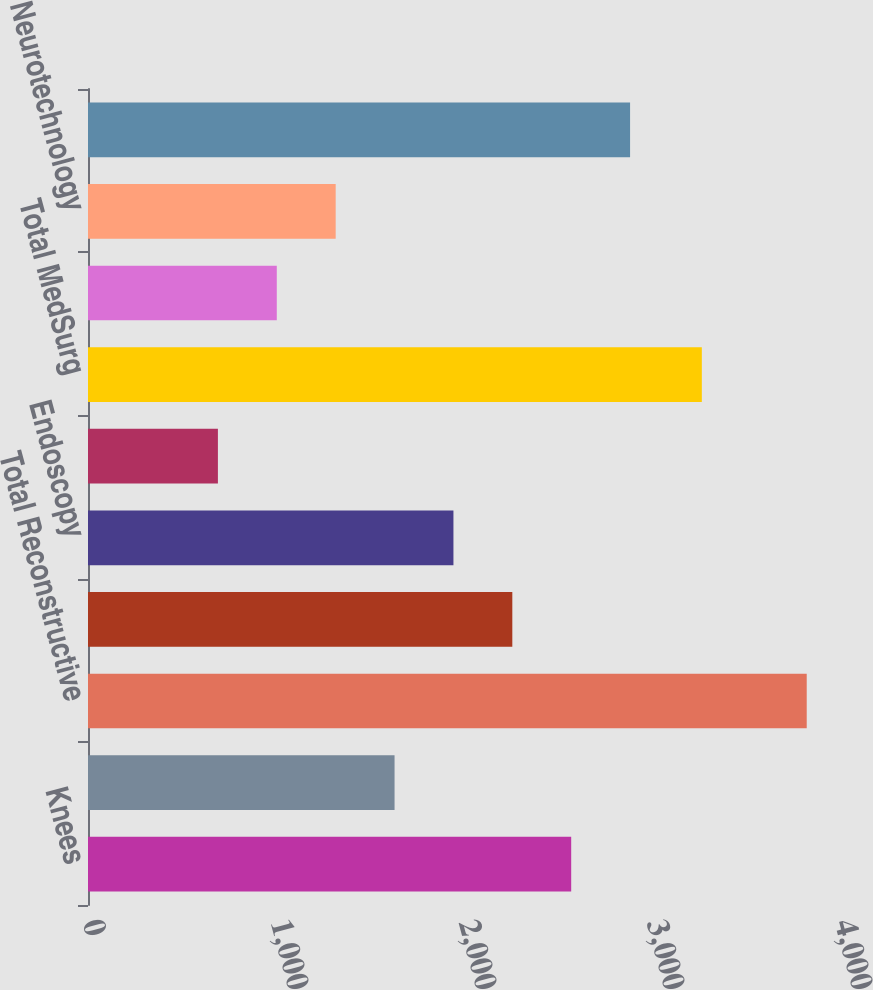Convert chart to OTSL. <chart><loc_0><loc_0><loc_500><loc_500><bar_chart><fcel>Knees<fcel>Trauma and Extremities<fcel>Total Reconstructive<fcel>Instruments<fcel>Endoscopy<fcel>Medical<fcel>Total MedSurg<fcel>Spine<fcel>Neurotechnology<fcel>Total Neurotechnology and<nl><fcel>2570.2<fcel>1630.6<fcel>3823<fcel>2257<fcel>1943.8<fcel>691<fcel>3265<fcel>1004.2<fcel>1317.4<fcel>2883.4<nl></chart> 